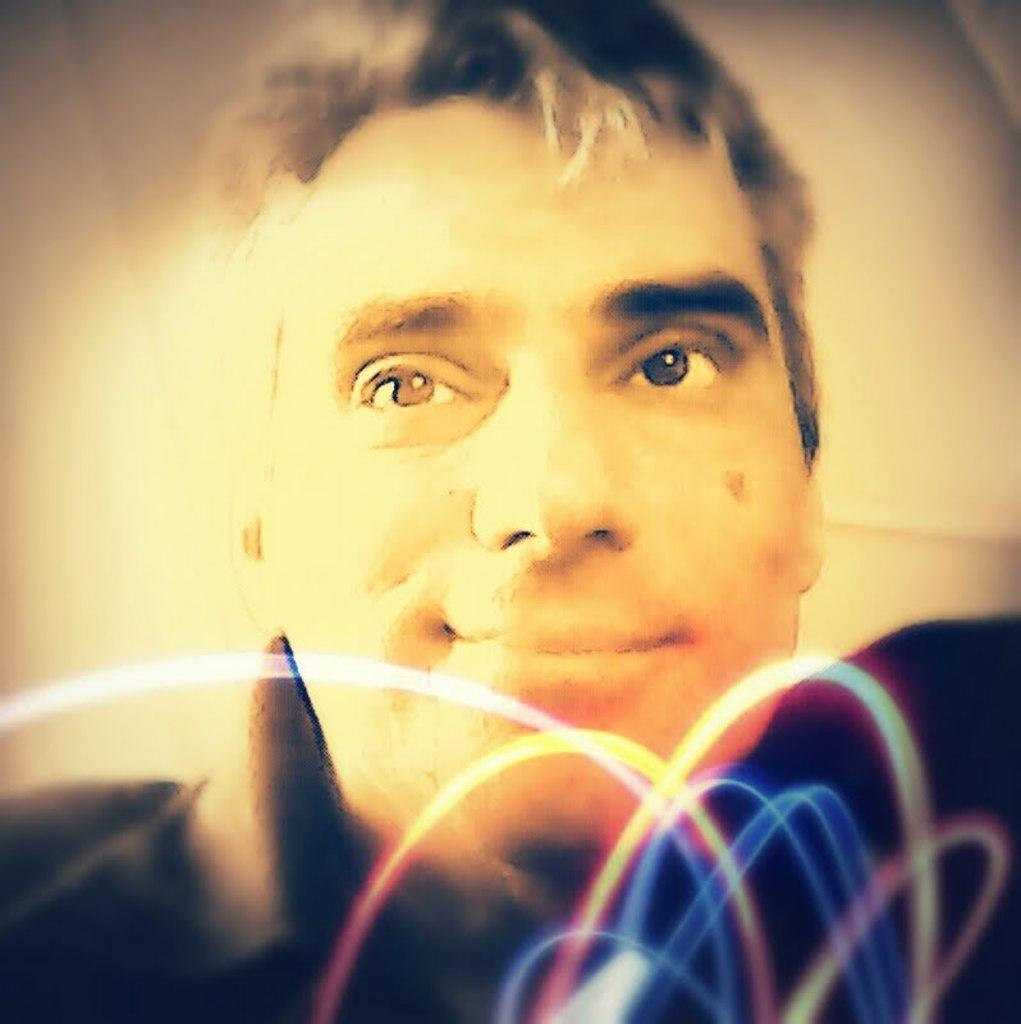Who is present in the image? There is a man in the image. What type of snake can be seen slithering around the man's leg in the image? There is no snake present in the image; only a man is visible. What kind of bone is the man holding in the image? There is no bone present in the image; only a man is visible. 